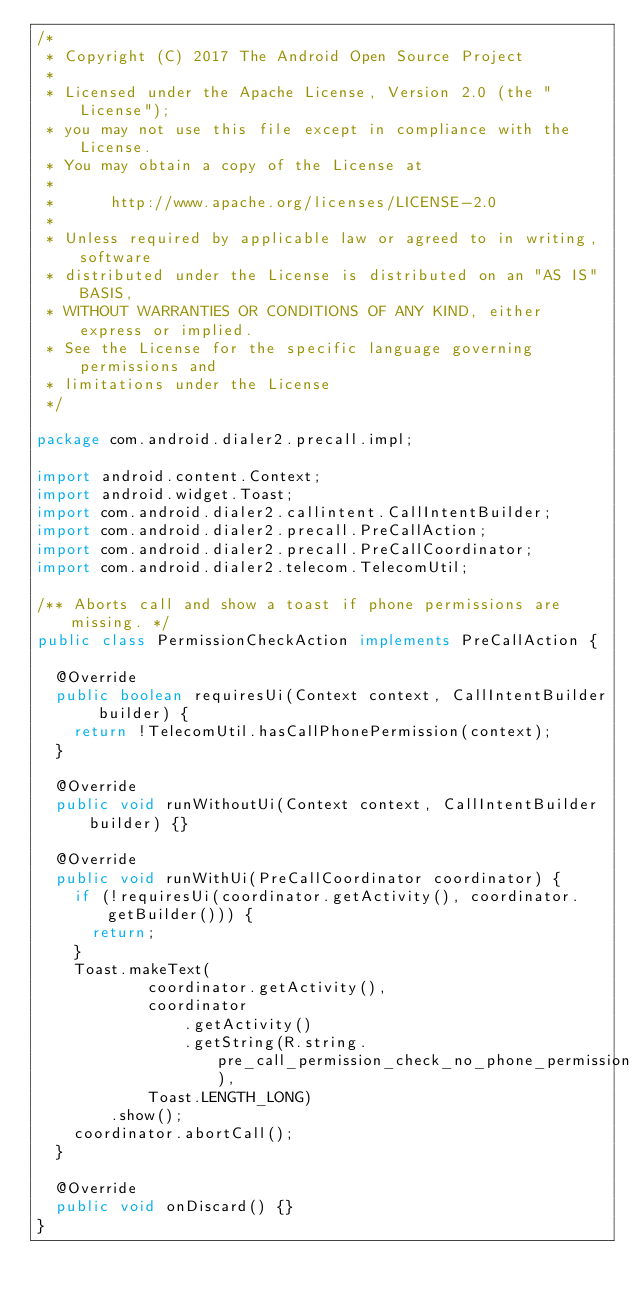<code> <loc_0><loc_0><loc_500><loc_500><_Java_>/*
 * Copyright (C) 2017 The Android Open Source Project
 *
 * Licensed under the Apache License, Version 2.0 (the "License");
 * you may not use this file except in compliance with the License.
 * You may obtain a copy of the License at
 *
 *      http://www.apache.org/licenses/LICENSE-2.0
 *
 * Unless required by applicable law or agreed to in writing, software
 * distributed under the License is distributed on an "AS IS" BASIS,
 * WITHOUT WARRANTIES OR CONDITIONS OF ANY KIND, either express or implied.
 * See the License for the specific language governing permissions and
 * limitations under the License
 */

package com.android.dialer2.precall.impl;

import android.content.Context;
import android.widget.Toast;
import com.android.dialer2.callintent.CallIntentBuilder;
import com.android.dialer2.precall.PreCallAction;
import com.android.dialer2.precall.PreCallCoordinator;
import com.android.dialer2.telecom.TelecomUtil;

/** Aborts call and show a toast if phone permissions are missing. */
public class PermissionCheckAction implements PreCallAction {

  @Override
  public boolean requiresUi(Context context, CallIntentBuilder builder) {
    return !TelecomUtil.hasCallPhonePermission(context);
  }

  @Override
  public void runWithoutUi(Context context, CallIntentBuilder builder) {}

  @Override
  public void runWithUi(PreCallCoordinator coordinator) {
    if (!requiresUi(coordinator.getActivity(), coordinator.getBuilder())) {
      return;
    }
    Toast.makeText(
            coordinator.getActivity(),
            coordinator
                .getActivity()
                .getString(R.string.pre_call_permission_check_no_phone_permission),
            Toast.LENGTH_LONG)
        .show();
    coordinator.abortCall();
  }

  @Override
  public void onDiscard() {}
}
</code> 